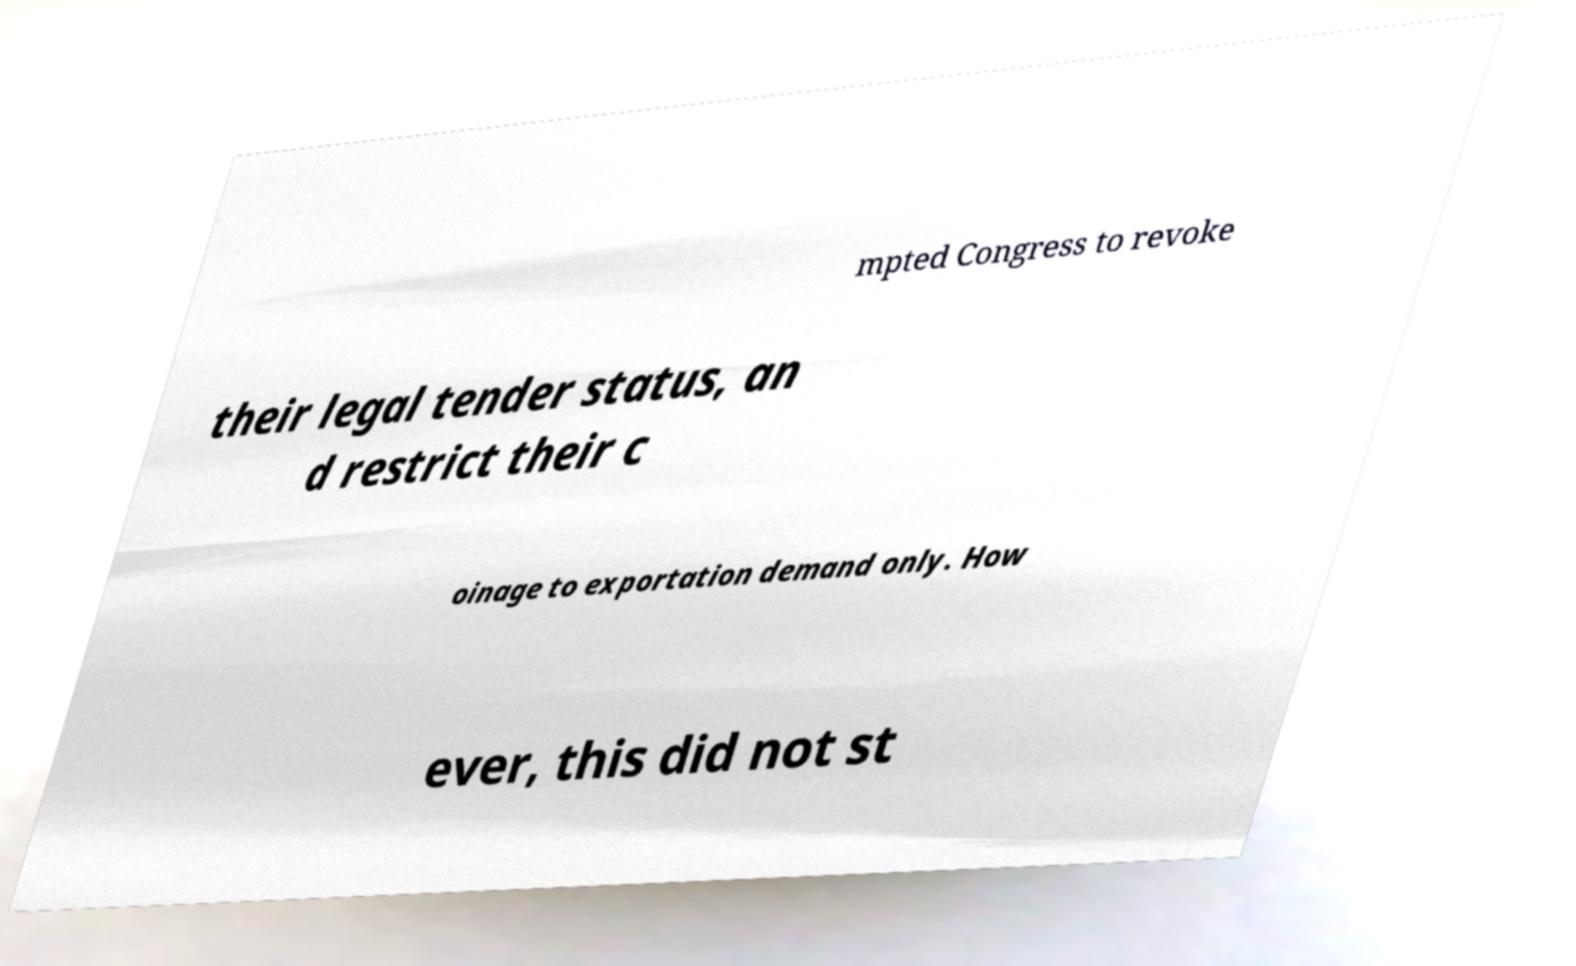Please identify and transcribe the text found in this image. mpted Congress to revoke their legal tender status, an d restrict their c oinage to exportation demand only. How ever, this did not st 